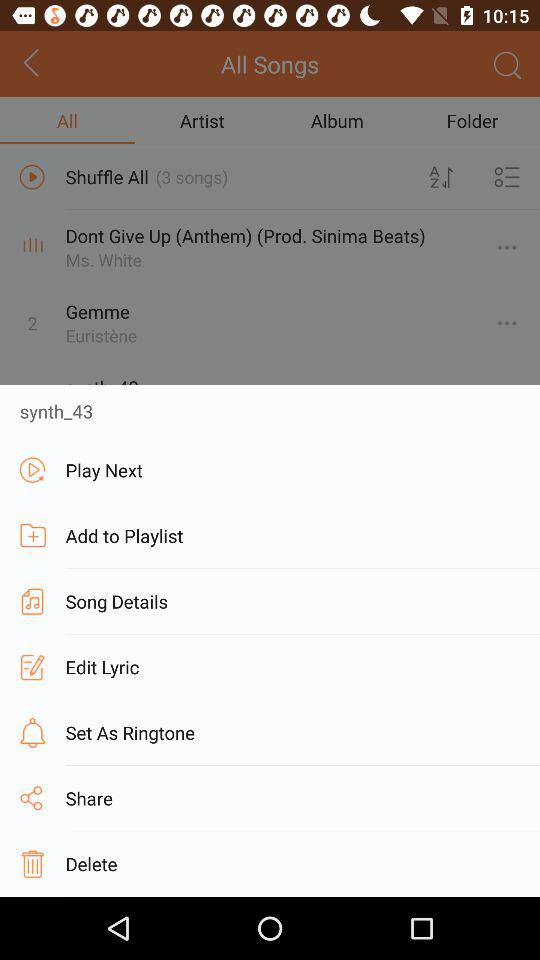How many songs are in "Shuffle All"? There are 3 songs in "Shuffle All". 